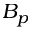<formula> <loc_0><loc_0><loc_500><loc_500>B _ { p }</formula> 